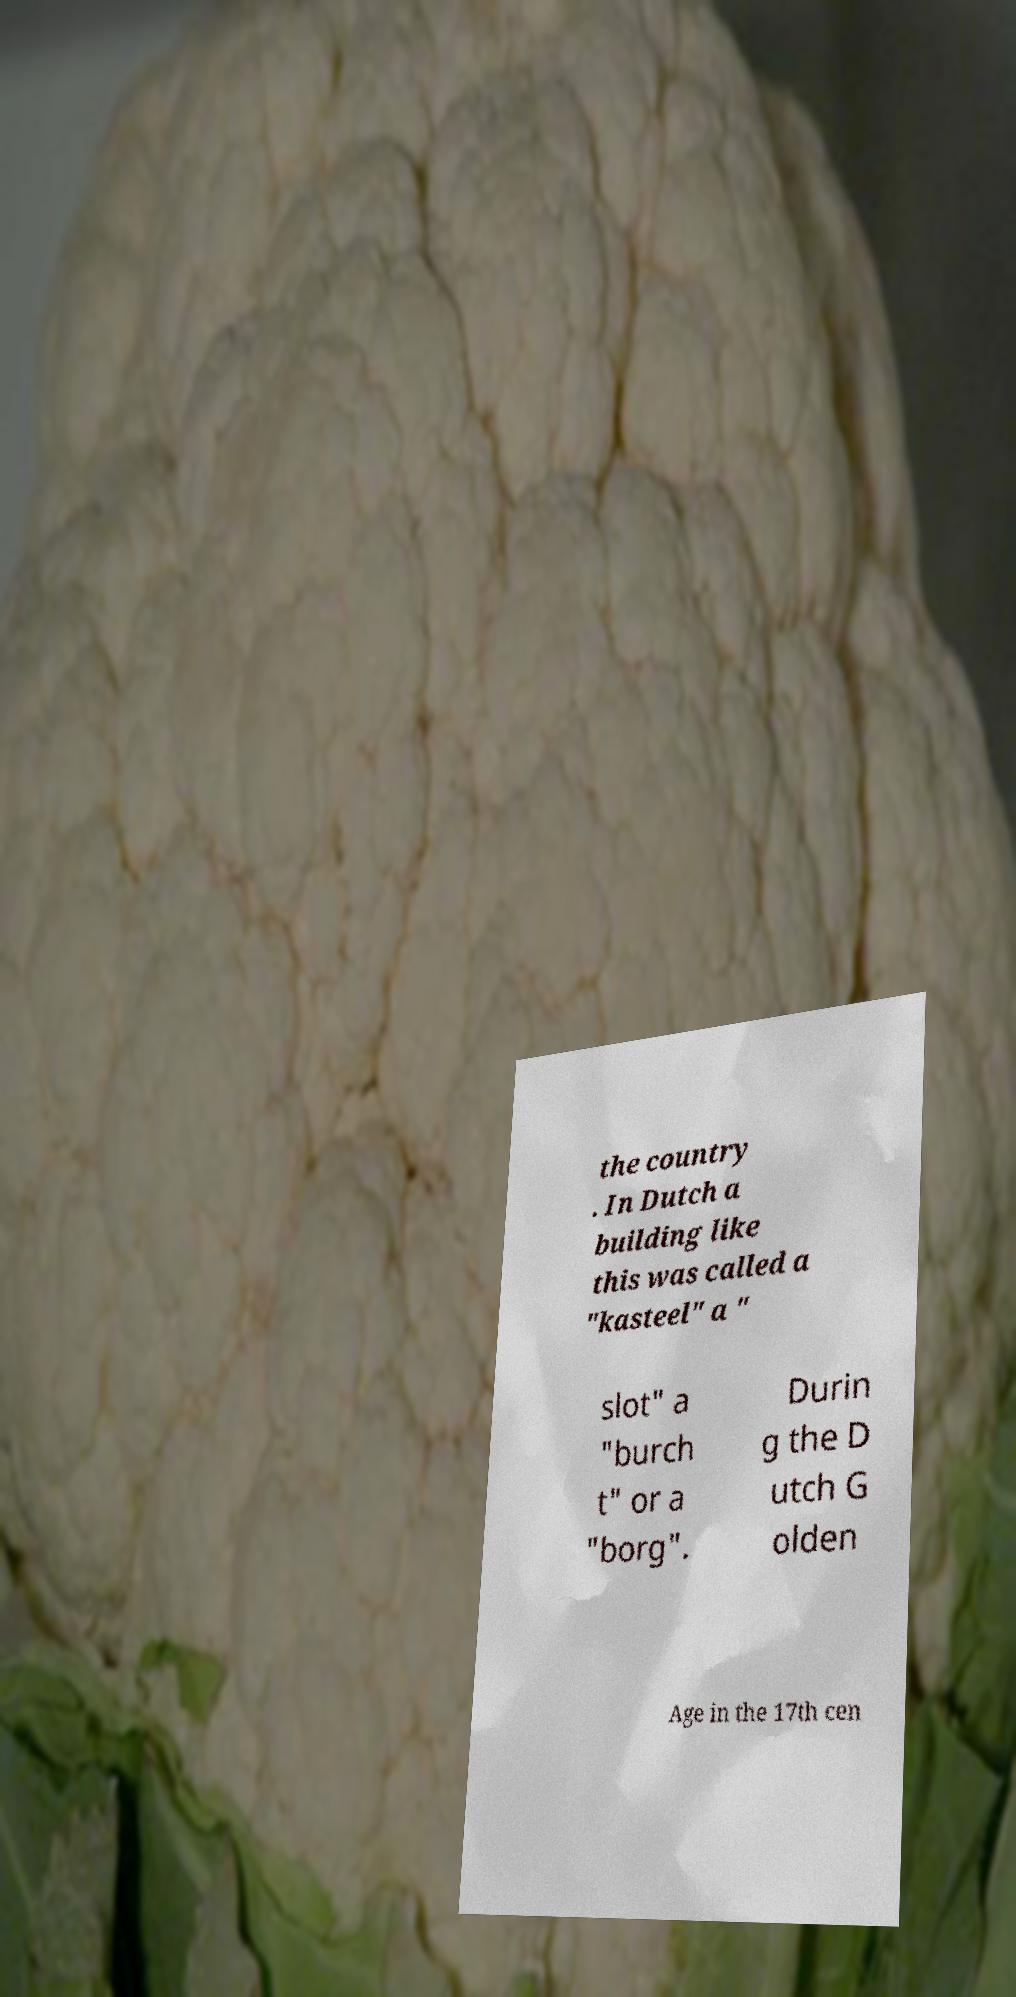Can you read and provide the text displayed in the image?This photo seems to have some interesting text. Can you extract and type it out for me? the country . In Dutch a building like this was called a "kasteel" a " slot" a "burch t" or a "borg". Durin g the D utch G olden Age in the 17th cen 